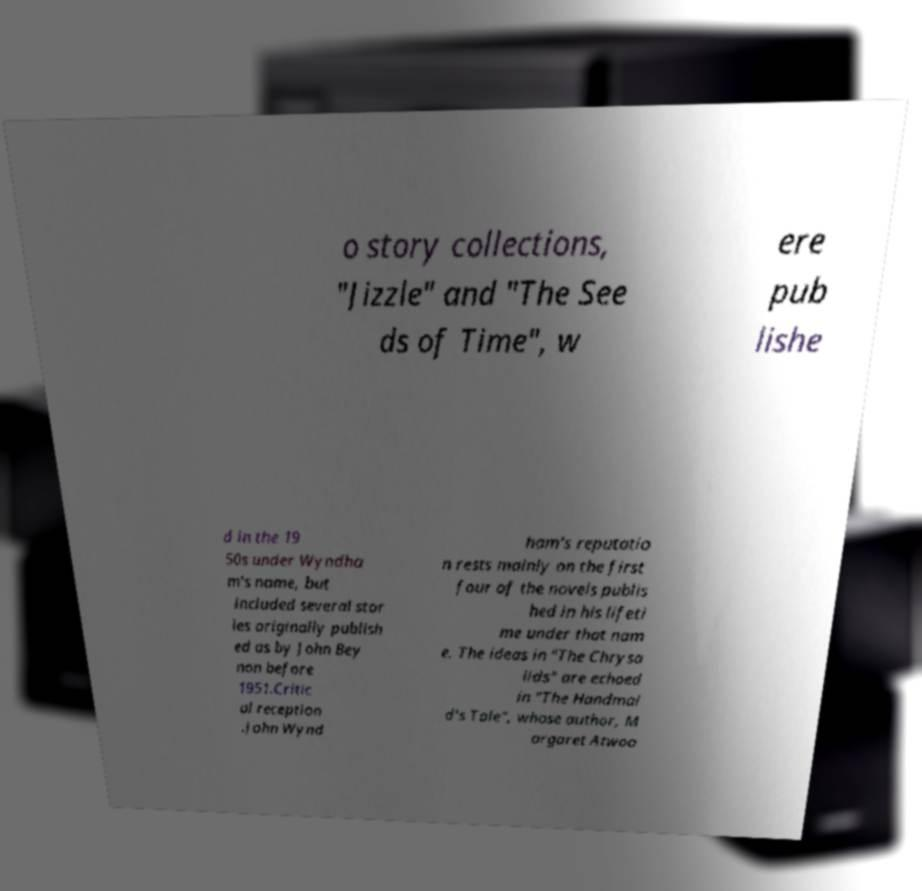Can you accurately transcribe the text from the provided image for me? o story collections, "Jizzle" and "The See ds of Time", w ere pub lishe d in the 19 50s under Wyndha m's name, but included several stor ies originally publish ed as by John Bey non before 1951.Critic al reception .John Wynd ham's reputatio n rests mainly on the first four of the novels publis hed in his lifeti me under that nam e. The ideas in "The Chrysa lids" are echoed in "The Handmai d's Tale", whose author, M argaret Atwoo 